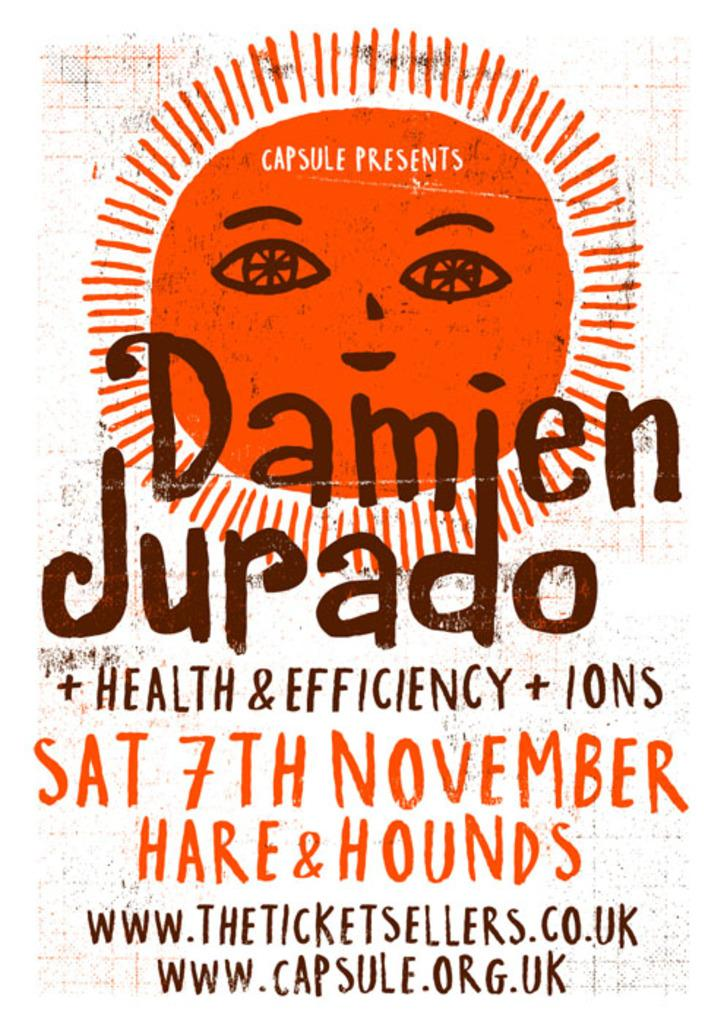What can be found in the image? There is text in the image. What type of eggnog is being served in the bedroom in the image? There is no eggnog or bedroom present in the image; it only contains text. 